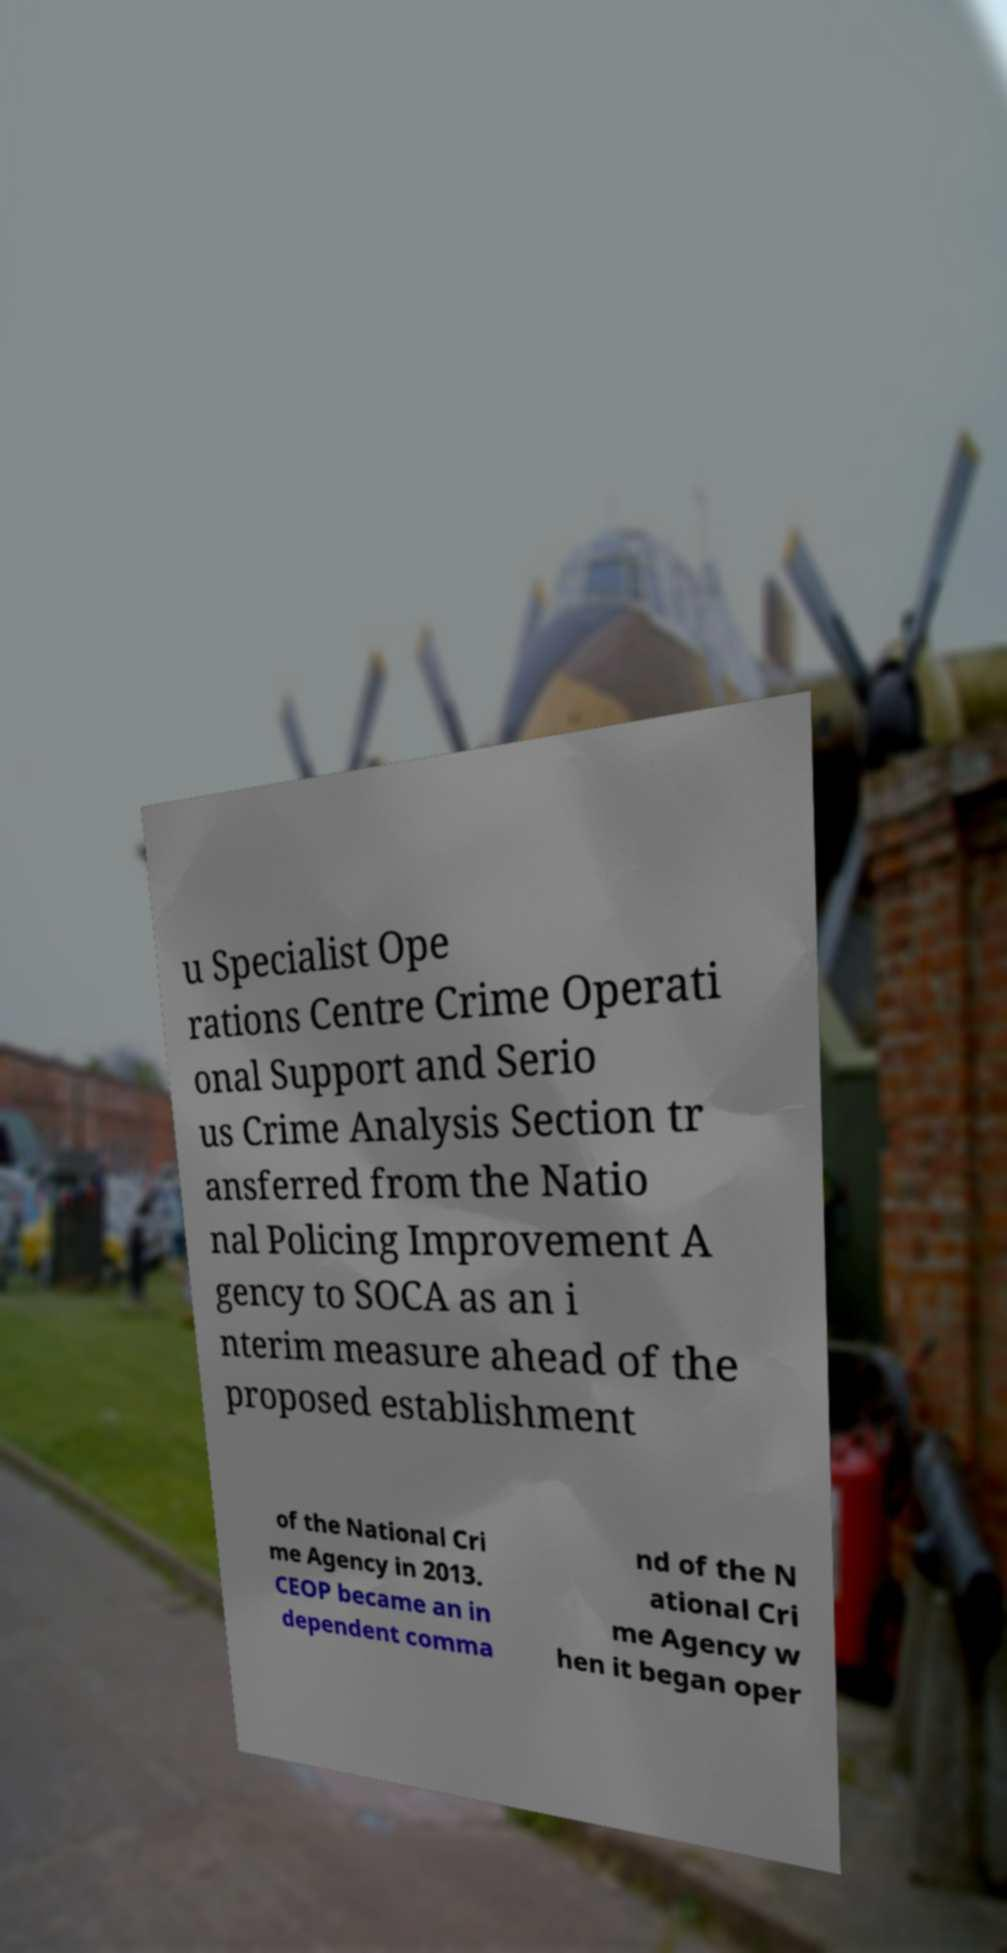Can you accurately transcribe the text from the provided image for me? u Specialist Ope rations Centre Crime Operati onal Support and Serio us Crime Analysis Section tr ansferred from the Natio nal Policing Improvement A gency to SOCA as an i nterim measure ahead of the proposed establishment of the National Cri me Agency in 2013. CEOP became an in dependent comma nd of the N ational Cri me Agency w hen it began oper 